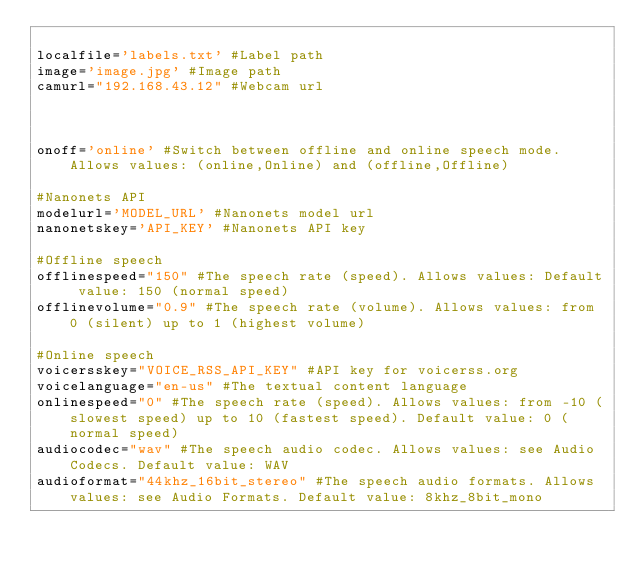<code> <loc_0><loc_0><loc_500><loc_500><_Python_>
localfile='labels.txt' #Label path
image='image.jpg' #Image path
camurl="192.168.43.12" #Webcam url



onoff='online' #Switch between offline and online speech mode. Allows values: (online,Online) and (offline,Offline)

#Nanonets API
modelurl='MODEL_URL' #Nanonets model url
nanonetskey='API_KEY' #Nanonets API key

#Offline speech
offlinespeed="150" #The speech rate (speed). Allows values: Default value: 150 (normal speed)
offlinevolume="0.9" #The speech rate (volume). Allows values: from 0 (silent) up to 1 (highest volume)

#Online speech
voicersskey="VOICE_RSS_API_KEY" #API key for voicerss.org
voicelanguage="en-us" #The textual content language
onlinespeed="0" #The speech rate (speed). Allows values: from -10 (slowest speed) up to 10 (fastest speed). Default value: 0 (normal speed)
audiocodec="wav" #The speech audio codec. Allows values: see Audio Codecs. Default value: WAV
audioformat="44khz_16bit_stereo" #The speech audio formats. Allows values: see Audio Formats. Default value: 8khz_8bit_mono</code> 